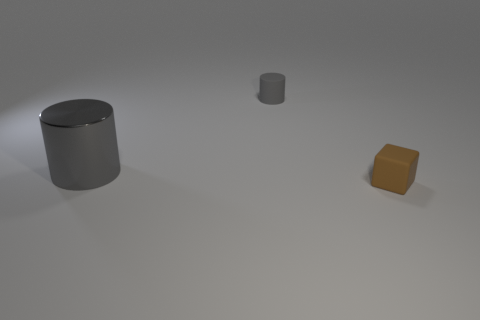Are there an equal number of matte things that are behind the metallic thing and small cylinders?
Give a very brief answer. Yes. Are there any shiny objects left of the large metallic cylinder?
Give a very brief answer. No. How many rubber objects are small cylinders or large blue cubes?
Provide a succinct answer. 1. There is a rubber block; what number of brown matte cubes are behind it?
Provide a short and direct response. 0. Are there any rubber cylinders that have the same size as the brown cube?
Give a very brief answer. Yes. Are there any small matte objects of the same color as the shiny object?
Keep it short and to the point. Yes. Are there any other things that are the same size as the matte cube?
Make the answer very short. Yes. How many small cylinders are the same color as the small rubber block?
Provide a succinct answer. 0. There is a small matte cylinder; is its color the same as the large cylinder that is to the left of the brown cube?
Provide a succinct answer. Yes. How many things are tiny gray rubber cylinders or objects that are on the right side of the shiny cylinder?
Make the answer very short. 2. 